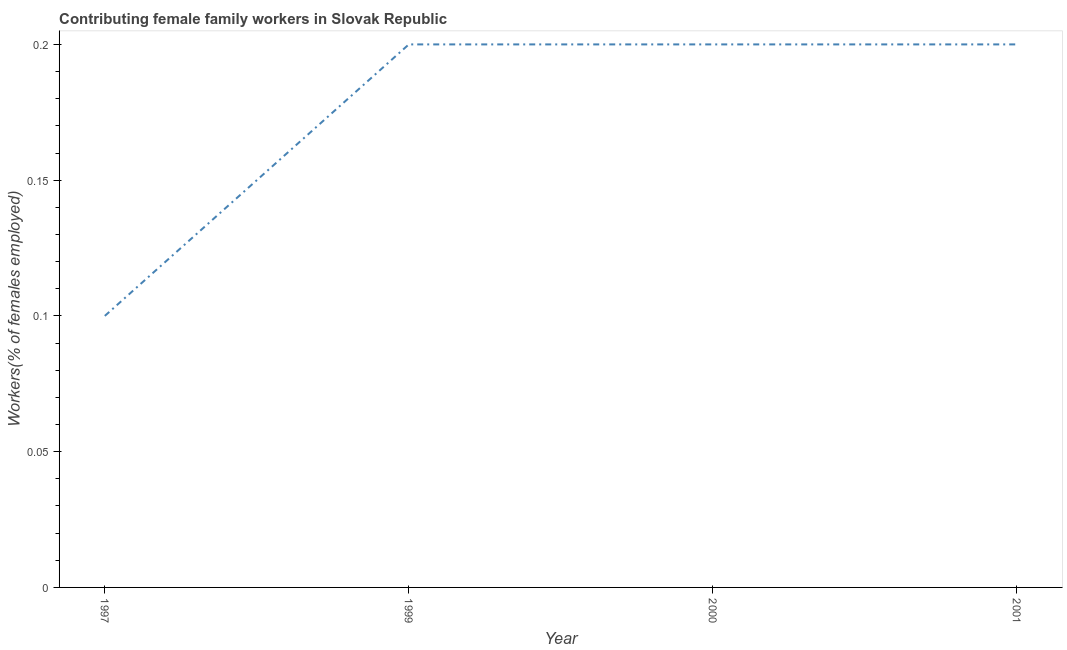What is the contributing female family workers in 2001?
Offer a very short reply. 0.2. Across all years, what is the maximum contributing female family workers?
Offer a terse response. 0.2. Across all years, what is the minimum contributing female family workers?
Provide a short and direct response. 0.1. In which year was the contributing female family workers maximum?
Offer a terse response. 1999. In which year was the contributing female family workers minimum?
Provide a succinct answer. 1997. What is the sum of the contributing female family workers?
Ensure brevity in your answer.  0.7. What is the average contributing female family workers per year?
Your answer should be compact. 0.18. What is the median contributing female family workers?
Offer a very short reply. 0.2. In how many years, is the contributing female family workers greater than 0.03 %?
Offer a very short reply. 4. Is the contributing female family workers in 1997 less than that in 2001?
Offer a very short reply. Yes. Is the sum of the contributing female family workers in 2000 and 2001 greater than the maximum contributing female family workers across all years?
Offer a terse response. Yes. What is the difference between the highest and the lowest contributing female family workers?
Your answer should be compact. 0.1. How many lines are there?
Offer a very short reply. 1. How many years are there in the graph?
Your response must be concise. 4. Are the values on the major ticks of Y-axis written in scientific E-notation?
Make the answer very short. No. Does the graph contain any zero values?
Provide a short and direct response. No. Does the graph contain grids?
Keep it short and to the point. No. What is the title of the graph?
Your response must be concise. Contributing female family workers in Slovak Republic. What is the label or title of the Y-axis?
Give a very brief answer. Workers(% of females employed). What is the Workers(% of females employed) in 1997?
Make the answer very short. 0.1. What is the Workers(% of females employed) in 1999?
Provide a short and direct response. 0.2. What is the Workers(% of females employed) of 2000?
Provide a short and direct response. 0.2. What is the Workers(% of females employed) of 2001?
Keep it short and to the point. 0.2. What is the difference between the Workers(% of females employed) in 1997 and 2001?
Your response must be concise. -0.1. What is the ratio of the Workers(% of females employed) in 1997 to that in 1999?
Offer a very short reply. 0.5. What is the ratio of the Workers(% of females employed) in 1997 to that in 2000?
Offer a terse response. 0.5. What is the ratio of the Workers(% of females employed) in 1997 to that in 2001?
Offer a very short reply. 0.5. What is the ratio of the Workers(% of females employed) in 1999 to that in 2000?
Your answer should be very brief. 1. What is the ratio of the Workers(% of females employed) in 1999 to that in 2001?
Ensure brevity in your answer.  1. What is the ratio of the Workers(% of females employed) in 2000 to that in 2001?
Keep it short and to the point. 1. 